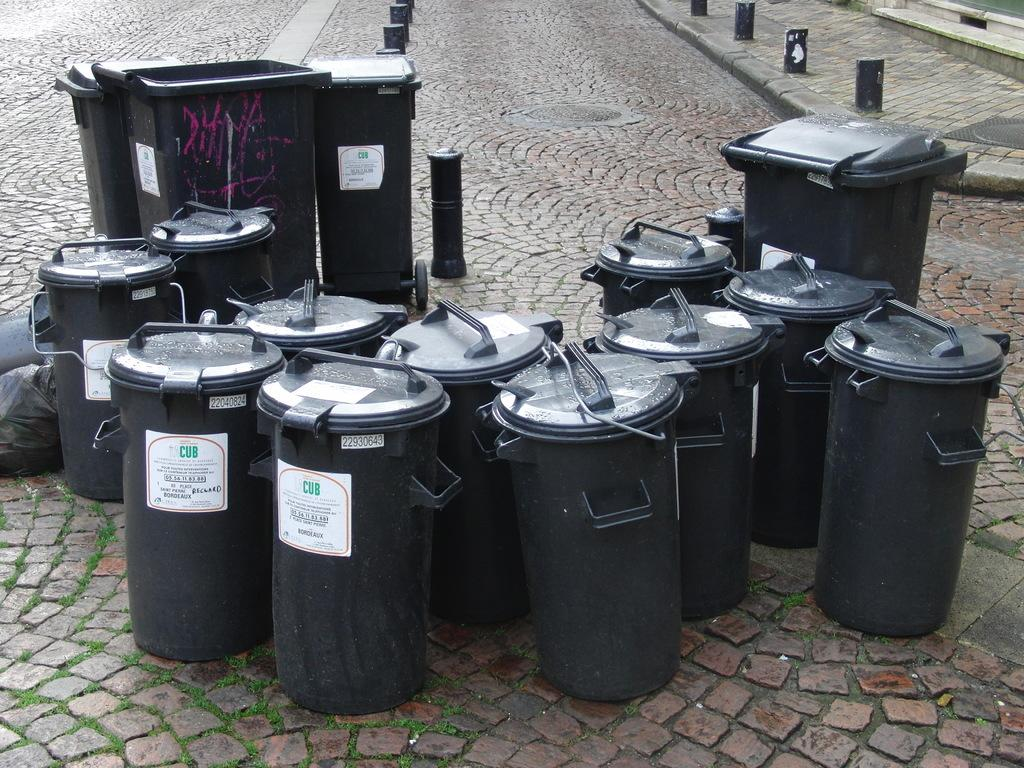<image>
Provide a brief description of the given image. Many trashcans that say CUB on them are together on the street. 